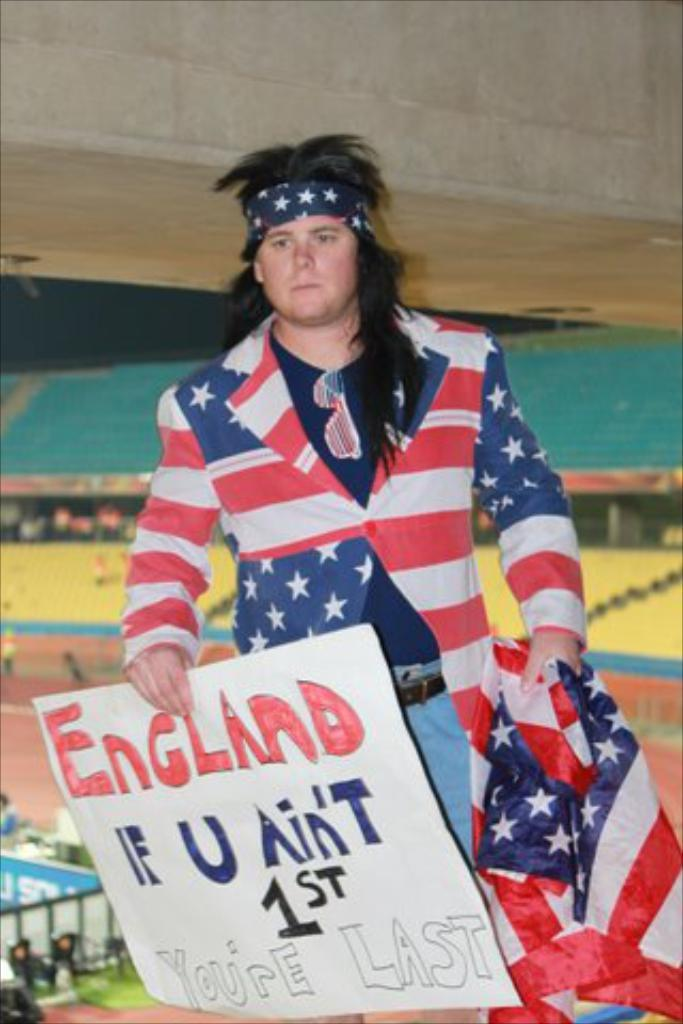<image>
Present a compact description of the photo's key features. A person wearing an American flag suit holds a sign that says England If U Ain't 1st You're Last. 